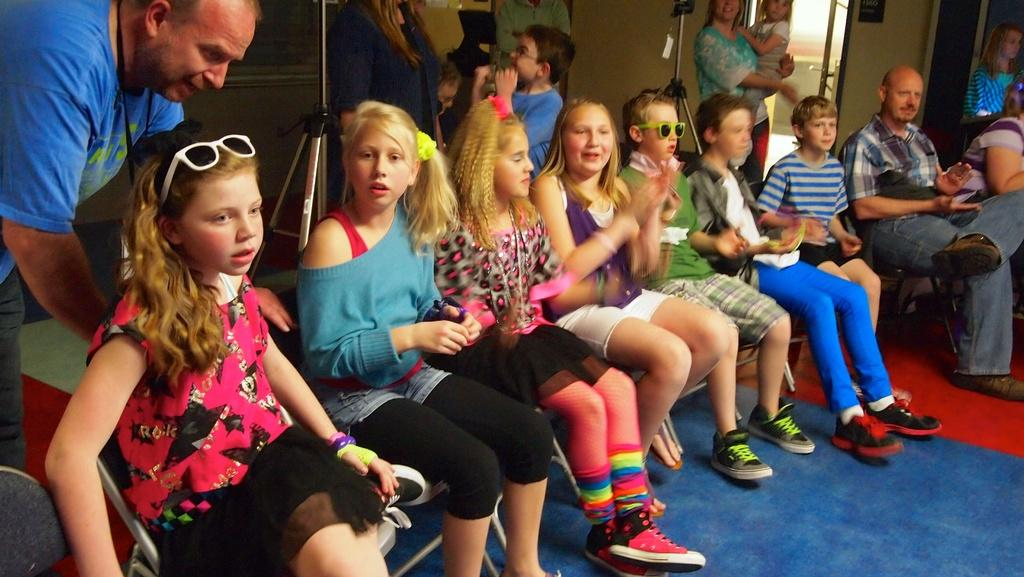What are the people in the image doing? The people in the image are sitting on chairs or standing on the floor. What can be seen in the background of the image? There are walls and tripods in the background of the image. What type of jewel is being used to enhance the learning experience in the image? There is no jewel or learning experience depicted in the image; it simply shows people sitting or standing. 